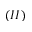<formula> <loc_0><loc_0><loc_500><loc_500>( I I )</formula> 